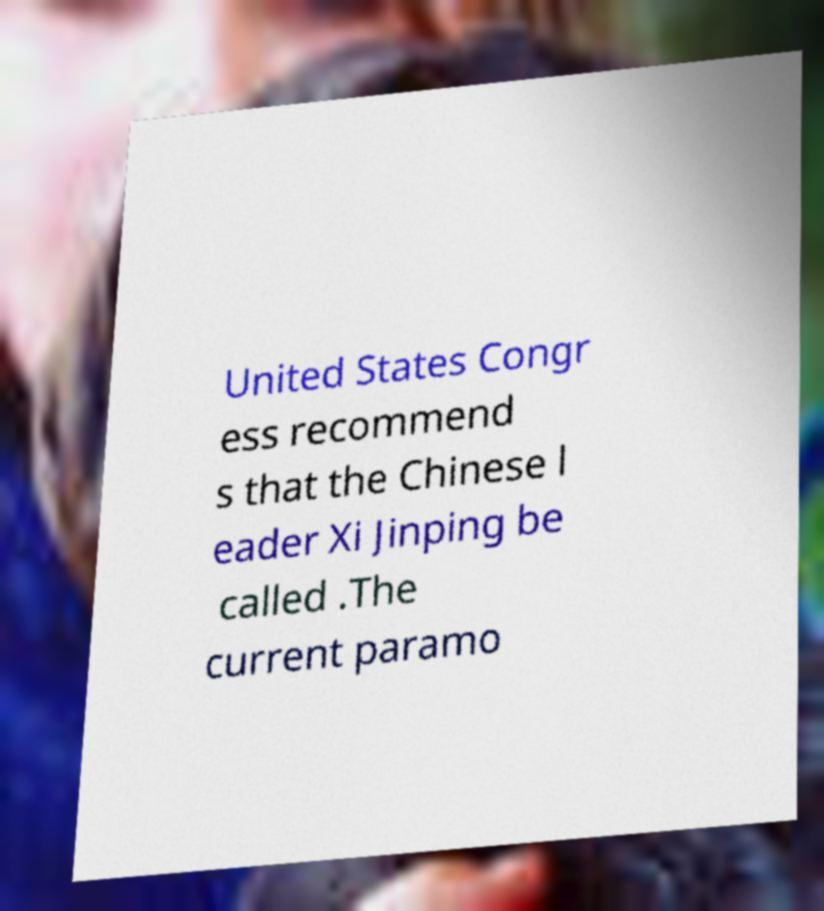Can you read and provide the text displayed in the image?This photo seems to have some interesting text. Can you extract and type it out for me? United States Congr ess recommend s that the Chinese l eader Xi Jinping be called .The current paramo 